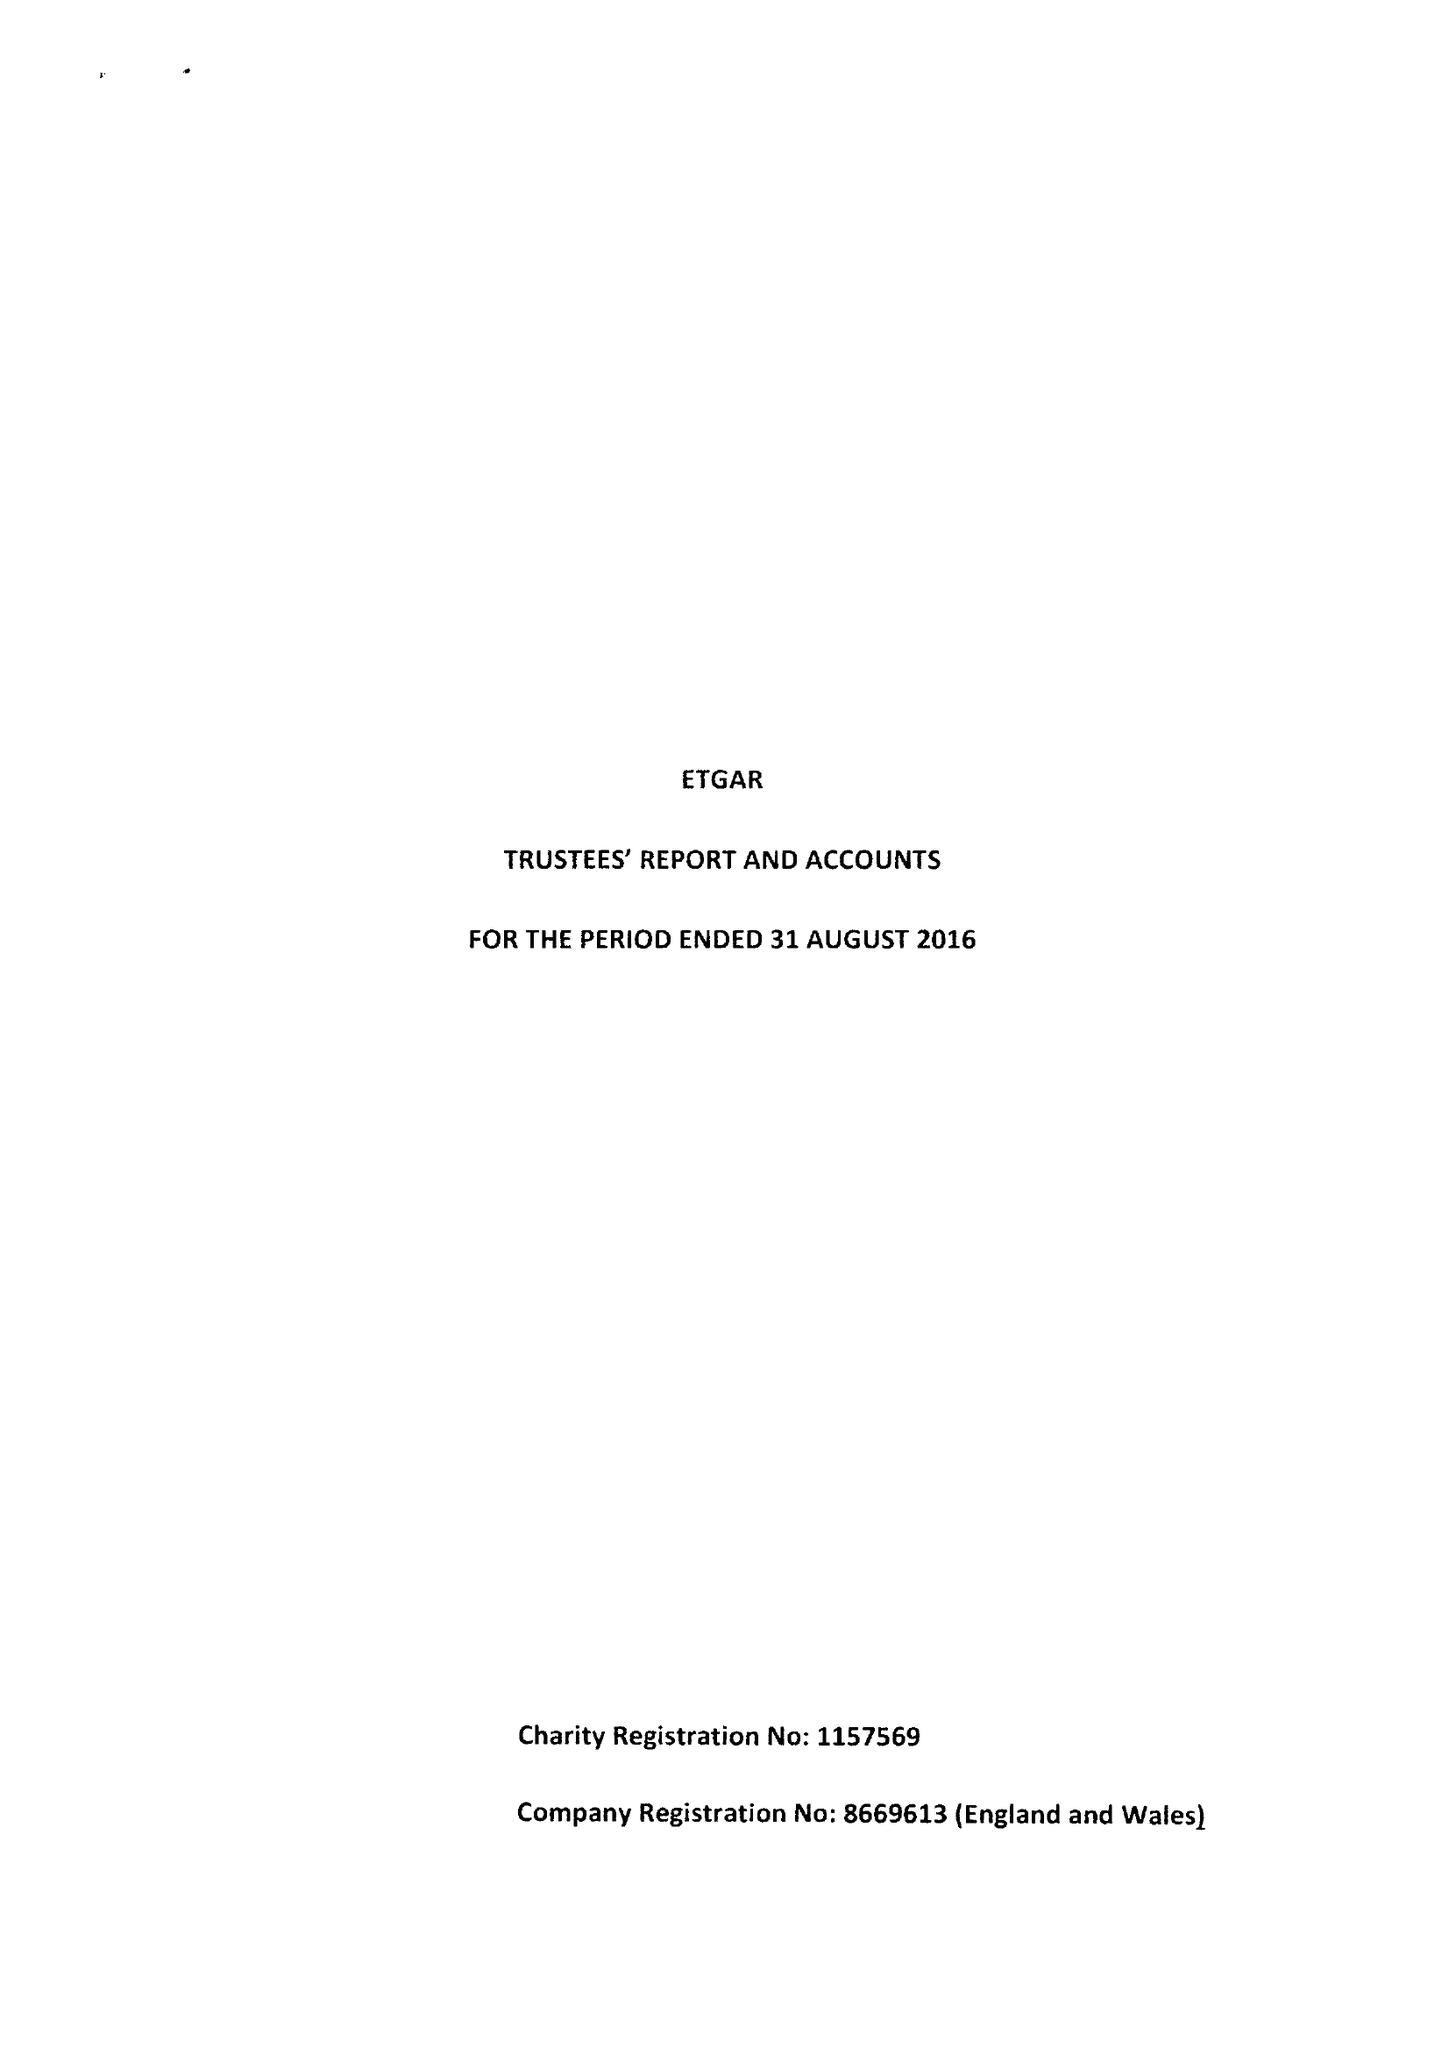What is the value for the address__post_town?
Answer the question using a single word or phrase. LONDON 